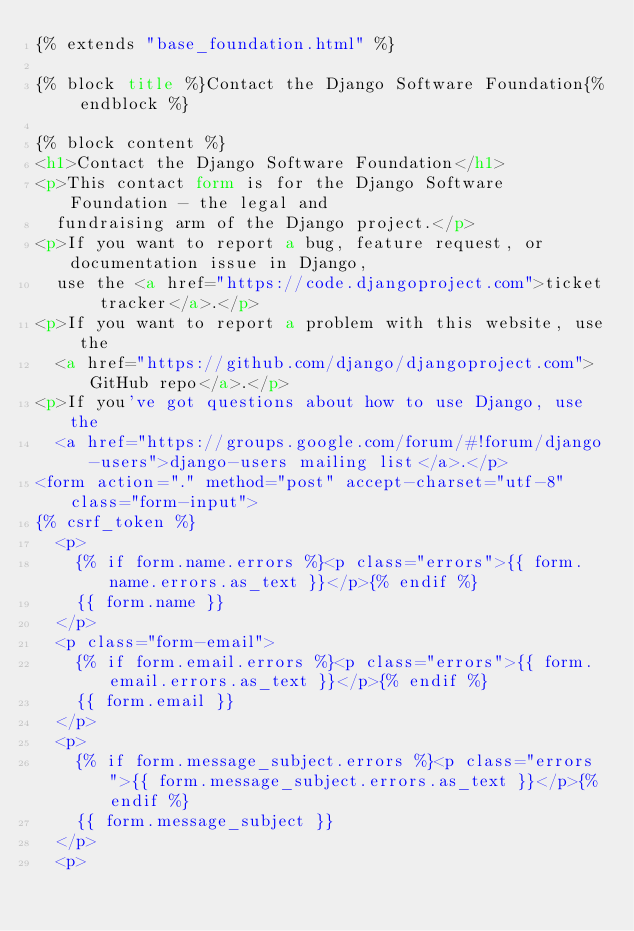Convert code to text. <code><loc_0><loc_0><loc_500><loc_500><_HTML_>{% extends "base_foundation.html" %}

{% block title %}Contact the Django Software Foundation{% endblock %}

{% block content %}
<h1>Contact the Django Software Foundation</h1>
<p>This contact form is for the Django Software Foundation - the legal and
  fundraising arm of the Django project.</p>
<p>If you want to report a bug, feature request, or documentation issue in Django,
  use the <a href="https://code.djangoproject.com">ticket tracker</a>.</p>
<p>If you want to report a problem with this website, use the
  <a href="https://github.com/django/djangoproject.com">GitHub repo</a>.</p>
<p>If you've got questions about how to use Django, use the
  <a href="https://groups.google.com/forum/#!forum/django-users">django-users mailing list</a>.</p>
<form action="." method="post" accept-charset="utf-8" class="form-input">
{% csrf_token %}
  <p>
    {% if form.name.errors %}<p class="errors">{{ form.name.errors.as_text }}</p>{% endif %}
    {{ form.name }}
  </p>
  <p class="form-email">
    {% if form.email.errors %}<p class="errors">{{ form.email.errors.as_text }}</p>{% endif %}
    {{ form.email }}
  </p>
  <p>
    {% if form.message_subject.errors %}<p class="errors">{{ form.message_subject.errors.as_text }}</p>{% endif %}
    {{ form.message_subject }}
  </p>
  <p></code> 